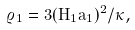Convert formula to latex. <formula><loc_0><loc_0><loc_500><loc_500>\varrho _ { 1 } = 3 ( H _ { 1 } a _ { 1 } ) ^ { 2 } / \kappa ,</formula> 